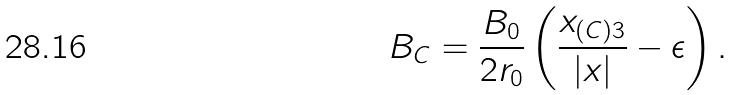Convert formula to latex. <formula><loc_0><loc_0><loc_500><loc_500>B _ { C } = \frac { B _ { 0 } } { 2 r _ { 0 } } \left ( \frac { x _ { ( C ) 3 } } { | { x } | } - \epsilon \right ) .</formula> 